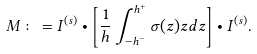Convert formula to latex. <formula><loc_0><loc_0><loc_500><loc_500>M \colon = I ^ { ( s ) } \bullet \left [ \frac { 1 } { h } \int ^ { h ^ { + } } _ { - h ^ { - } } \sigma ( z ) z d z \right ] \bullet I ^ { ( s ) } .</formula> 